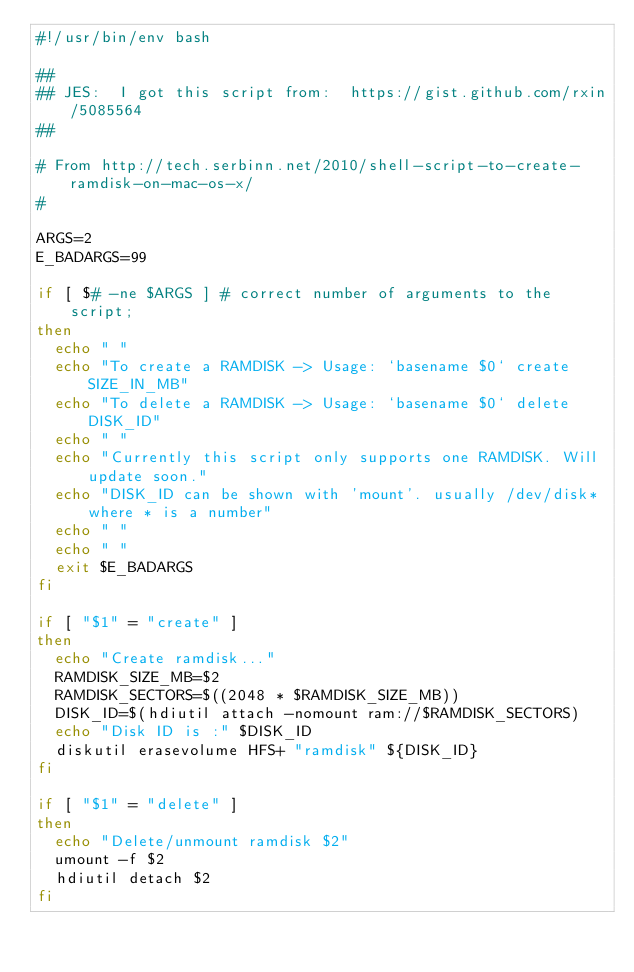<code> <loc_0><loc_0><loc_500><loc_500><_Bash_>#!/usr/bin/env bash

##
## JES:  I got this script from:  https://gist.github.com/rxin/5085564
##

# From http://tech.serbinn.net/2010/shell-script-to-create-ramdisk-on-mac-os-x/
#

ARGS=2
E_BADARGS=99

if [ $# -ne $ARGS ] # correct number of arguments to the script;
then
  echo " "
  echo "To create a RAMDISK -> Usage: `basename $0` create SIZE_IN_MB"
  echo "To delete a RAMDISK -> Usage: `basename $0` delete DISK_ID"
  echo " "
  echo "Currently this script only supports one RAMDISK. Will update soon."
  echo "DISK_ID can be shown with 'mount'. usually /dev/disk* where * is a number"
  echo " "
  echo " "
  exit $E_BADARGS
fi

if [ "$1" = "create" ]
then
  echo "Create ramdisk..."
  RAMDISK_SIZE_MB=$2
  RAMDISK_SECTORS=$((2048 * $RAMDISK_SIZE_MB))
  DISK_ID=$(hdiutil attach -nomount ram://$RAMDISK_SECTORS)
  echo "Disk ID is :" $DISK_ID
  diskutil erasevolume HFS+ "ramdisk" ${DISK_ID}
fi

if [ "$1" = "delete" ]
then
  echo "Delete/unmount ramdisk $2"
  umount -f $2
  hdiutil detach $2
fi

</code> 